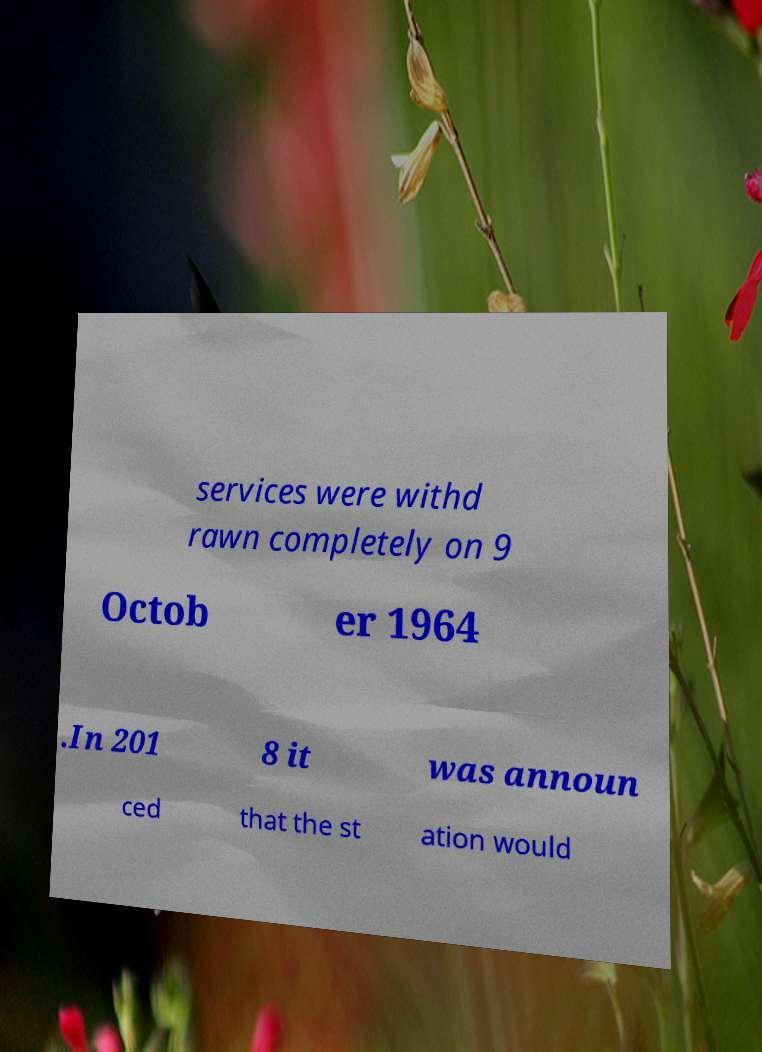Please identify and transcribe the text found in this image. services were withd rawn completely on 9 Octob er 1964 .In 201 8 it was announ ced that the st ation would 